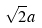<formula> <loc_0><loc_0><loc_500><loc_500>\sqrt { 2 } a</formula> 